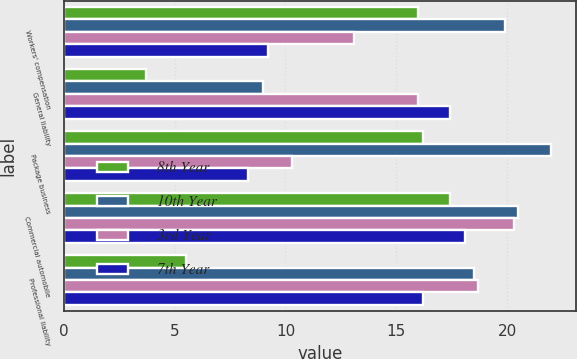<chart> <loc_0><loc_0><loc_500><loc_500><stacked_bar_chart><ecel><fcel>Workers' compensation<fcel>General liability<fcel>Package business<fcel>Commercial automobile<fcel>Professional liability<nl><fcel>8th Year<fcel>16<fcel>3.7<fcel>16.2<fcel>17.4<fcel>5.5<nl><fcel>10th Year<fcel>19.9<fcel>9<fcel>22<fcel>20.5<fcel>18.5<nl><fcel>3rd Year<fcel>13.1<fcel>16<fcel>10.3<fcel>20.3<fcel>18.7<nl><fcel>7th Year<fcel>9.2<fcel>17.4<fcel>8.3<fcel>18.1<fcel>16.2<nl></chart> 